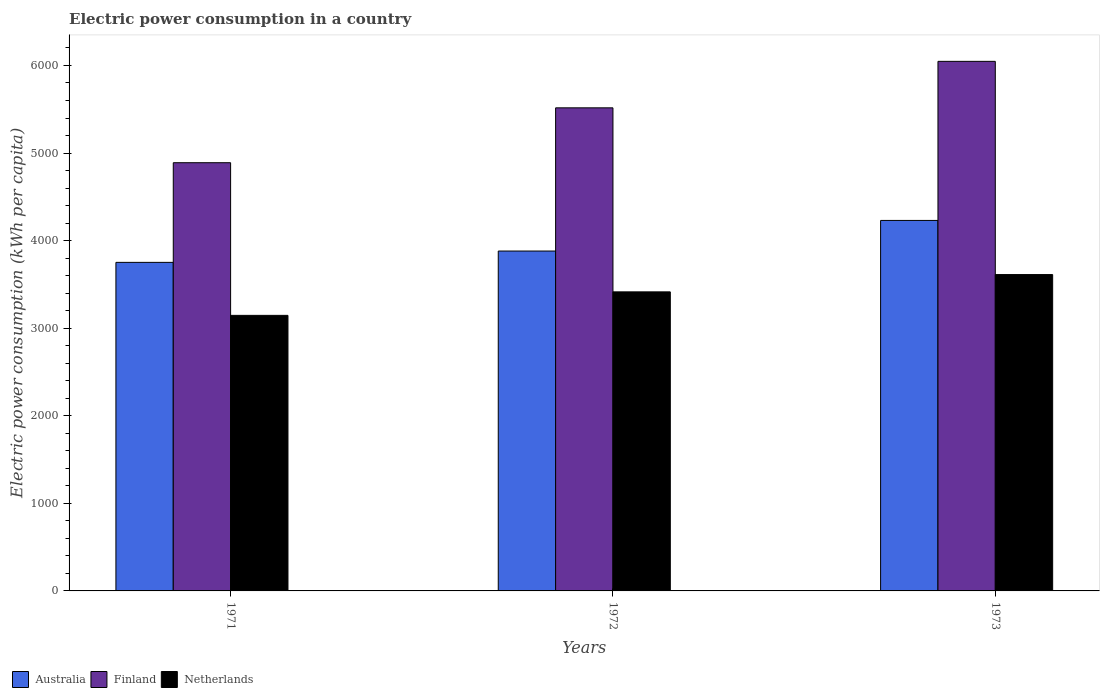How many groups of bars are there?
Your answer should be compact. 3. Are the number of bars on each tick of the X-axis equal?
Offer a very short reply. Yes. What is the label of the 2nd group of bars from the left?
Make the answer very short. 1972. In how many cases, is the number of bars for a given year not equal to the number of legend labels?
Provide a short and direct response. 0. What is the electric power consumption in in Australia in 1972?
Offer a terse response. 3880.93. Across all years, what is the maximum electric power consumption in in Australia?
Offer a very short reply. 4230.34. Across all years, what is the minimum electric power consumption in in Finland?
Provide a succinct answer. 4889.5. In which year was the electric power consumption in in Finland minimum?
Your response must be concise. 1971. What is the total electric power consumption in in Australia in the graph?
Ensure brevity in your answer.  1.19e+04. What is the difference between the electric power consumption in in Finland in 1971 and that in 1972?
Your response must be concise. -626.64. What is the difference between the electric power consumption in in Australia in 1973 and the electric power consumption in in Netherlands in 1971?
Your answer should be very brief. 1083.88. What is the average electric power consumption in in Finland per year?
Ensure brevity in your answer.  5484.16. In the year 1971, what is the difference between the electric power consumption in in Netherlands and electric power consumption in in Finland?
Ensure brevity in your answer.  -1743.04. In how many years, is the electric power consumption in in Netherlands greater than 2200 kWh per capita?
Make the answer very short. 3. What is the ratio of the electric power consumption in in Netherlands in 1972 to that in 1973?
Provide a short and direct response. 0.95. Is the electric power consumption in in Netherlands in 1971 less than that in 1972?
Your answer should be very brief. Yes. What is the difference between the highest and the second highest electric power consumption in in Australia?
Your answer should be very brief. 349.41. What is the difference between the highest and the lowest electric power consumption in in Netherlands?
Your answer should be compact. 465.85. Is the sum of the electric power consumption in in Netherlands in 1972 and 1973 greater than the maximum electric power consumption in in Australia across all years?
Ensure brevity in your answer.  Yes. What does the 2nd bar from the left in 1971 represents?
Ensure brevity in your answer.  Finland. Is it the case that in every year, the sum of the electric power consumption in in Finland and electric power consumption in in Australia is greater than the electric power consumption in in Netherlands?
Your answer should be compact. Yes. How many bars are there?
Give a very brief answer. 9. Are all the bars in the graph horizontal?
Ensure brevity in your answer.  No. How many years are there in the graph?
Offer a very short reply. 3. What is the difference between two consecutive major ticks on the Y-axis?
Your answer should be compact. 1000. Does the graph contain any zero values?
Make the answer very short. No. Where does the legend appear in the graph?
Ensure brevity in your answer.  Bottom left. How many legend labels are there?
Provide a short and direct response. 3. How are the legend labels stacked?
Your answer should be very brief. Horizontal. What is the title of the graph?
Make the answer very short. Electric power consumption in a country. What is the label or title of the Y-axis?
Provide a succinct answer. Electric power consumption (kWh per capita). What is the Electric power consumption (kWh per capita) in Australia in 1971?
Provide a short and direct response. 3751.64. What is the Electric power consumption (kWh per capita) of Finland in 1971?
Make the answer very short. 4889.5. What is the Electric power consumption (kWh per capita) of Netherlands in 1971?
Provide a short and direct response. 3146.46. What is the Electric power consumption (kWh per capita) of Australia in 1972?
Your answer should be compact. 3880.93. What is the Electric power consumption (kWh per capita) in Finland in 1972?
Provide a short and direct response. 5516.14. What is the Electric power consumption (kWh per capita) of Netherlands in 1972?
Your response must be concise. 3414.69. What is the Electric power consumption (kWh per capita) of Australia in 1973?
Your answer should be compact. 4230.34. What is the Electric power consumption (kWh per capita) in Finland in 1973?
Your response must be concise. 6046.83. What is the Electric power consumption (kWh per capita) in Netherlands in 1973?
Your answer should be very brief. 3612.31. Across all years, what is the maximum Electric power consumption (kWh per capita) of Australia?
Your answer should be very brief. 4230.34. Across all years, what is the maximum Electric power consumption (kWh per capita) of Finland?
Provide a short and direct response. 6046.83. Across all years, what is the maximum Electric power consumption (kWh per capita) in Netherlands?
Your answer should be very brief. 3612.31. Across all years, what is the minimum Electric power consumption (kWh per capita) in Australia?
Offer a very short reply. 3751.64. Across all years, what is the minimum Electric power consumption (kWh per capita) in Finland?
Your response must be concise. 4889.5. Across all years, what is the minimum Electric power consumption (kWh per capita) of Netherlands?
Offer a terse response. 3146.46. What is the total Electric power consumption (kWh per capita) in Australia in the graph?
Give a very brief answer. 1.19e+04. What is the total Electric power consumption (kWh per capita) of Finland in the graph?
Keep it short and to the point. 1.65e+04. What is the total Electric power consumption (kWh per capita) of Netherlands in the graph?
Your answer should be very brief. 1.02e+04. What is the difference between the Electric power consumption (kWh per capita) in Australia in 1971 and that in 1972?
Make the answer very short. -129.29. What is the difference between the Electric power consumption (kWh per capita) in Finland in 1971 and that in 1972?
Give a very brief answer. -626.64. What is the difference between the Electric power consumption (kWh per capita) of Netherlands in 1971 and that in 1972?
Keep it short and to the point. -268.23. What is the difference between the Electric power consumption (kWh per capita) of Australia in 1971 and that in 1973?
Offer a terse response. -478.7. What is the difference between the Electric power consumption (kWh per capita) of Finland in 1971 and that in 1973?
Your answer should be compact. -1157.33. What is the difference between the Electric power consumption (kWh per capita) in Netherlands in 1971 and that in 1973?
Make the answer very short. -465.85. What is the difference between the Electric power consumption (kWh per capita) in Australia in 1972 and that in 1973?
Your response must be concise. -349.41. What is the difference between the Electric power consumption (kWh per capita) of Finland in 1972 and that in 1973?
Offer a terse response. -530.69. What is the difference between the Electric power consumption (kWh per capita) of Netherlands in 1972 and that in 1973?
Make the answer very short. -197.62. What is the difference between the Electric power consumption (kWh per capita) in Australia in 1971 and the Electric power consumption (kWh per capita) in Finland in 1972?
Your answer should be compact. -1764.5. What is the difference between the Electric power consumption (kWh per capita) in Australia in 1971 and the Electric power consumption (kWh per capita) in Netherlands in 1972?
Provide a short and direct response. 336.95. What is the difference between the Electric power consumption (kWh per capita) of Finland in 1971 and the Electric power consumption (kWh per capita) of Netherlands in 1972?
Give a very brief answer. 1474.82. What is the difference between the Electric power consumption (kWh per capita) of Australia in 1971 and the Electric power consumption (kWh per capita) of Finland in 1973?
Give a very brief answer. -2295.19. What is the difference between the Electric power consumption (kWh per capita) of Australia in 1971 and the Electric power consumption (kWh per capita) of Netherlands in 1973?
Provide a succinct answer. 139.33. What is the difference between the Electric power consumption (kWh per capita) in Finland in 1971 and the Electric power consumption (kWh per capita) in Netherlands in 1973?
Give a very brief answer. 1277.19. What is the difference between the Electric power consumption (kWh per capita) in Australia in 1972 and the Electric power consumption (kWh per capita) in Finland in 1973?
Offer a terse response. -2165.9. What is the difference between the Electric power consumption (kWh per capita) of Australia in 1972 and the Electric power consumption (kWh per capita) of Netherlands in 1973?
Ensure brevity in your answer.  268.62. What is the difference between the Electric power consumption (kWh per capita) in Finland in 1972 and the Electric power consumption (kWh per capita) in Netherlands in 1973?
Offer a very short reply. 1903.83. What is the average Electric power consumption (kWh per capita) of Australia per year?
Your answer should be very brief. 3954.31. What is the average Electric power consumption (kWh per capita) in Finland per year?
Ensure brevity in your answer.  5484.16. What is the average Electric power consumption (kWh per capita) in Netherlands per year?
Offer a very short reply. 3391.15. In the year 1971, what is the difference between the Electric power consumption (kWh per capita) of Australia and Electric power consumption (kWh per capita) of Finland?
Provide a succinct answer. -1137.86. In the year 1971, what is the difference between the Electric power consumption (kWh per capita) of Australia and Electric power consumption (kWh per capita) of Netherlands?
Your answer should be compact. 605.18. In the year 1971, what is the difference between the Electric power consumption (kWh per capita) of Finland and Electric power consumption (kWh per capita) of Netherlands?
Provide a succinct answer. 1743.04. In the year 1972, what is the difference between the Electric power consumption (kWh per capita) in Australia and Electric power consumption (kWh per capita) in Finland?
Offer a terse response. -1635.21. In the year 1972, what is the difference between the Electric power consumption (kWh per capita) in Australia and Electric power consumption (kWh per capita) in Netherlands?
Offer a terse response. 466.24. In the year 1972, what is the difference between the Electric power consumption (kWh per capita) in Finland and Electric power consumption (kWh per capita) in Netherlands?
Your answer should be very brief. 2101.45. In the year 1973, what is the difference between the Electric power consumption (kWh per capita) of Australia and Electric power consumption (kWh per capita) of Finland?
Provide a short and direct response. -1816.49. In the year 1973, what is the difference between the Electric power consumption (kWh per capita) of Australia and Electric power consumption (kWh per capita) of Netherlands?
Offer a very short reply. 618.03. In the year 1973, what is the difference between the Electric power consumption (kWh per capita) in Finland and Electric power consumption (kWh per capita) in Netherlands?
Your answer should be very brief. 2434.52. What is the ratio of the Electric power consumption (kWh per capita) in Australia in 1971 to that in 1972?
Your answer should be compact. 0.97. What is the ratio of the Electric power consumption (kWh per capita) of Finland in 1971 to that in 1972?
Provide a short and direct response. 0.89. What is the ratio of the Electric power consumption (kWh per capita) in Netherlands in 1971 to that in 1972?
Ensure brevity in your answer.  0.92. What is the ratio of the Electric power consumption (kWh per capita) of Australia in 1971 to that in 1973?
Offer a very short reply. 0.89. What is the ratio of the Electric power consumption (kWh per capita) in Finland in 1971 to that in 1973?
Offer a terse response. 0.81. What is the ratio of the Electric power consumption (kWh per capita) of Netherlands in 1971 to that in 1973?
Your response must be concise. 0.87. What is the ratio of the Electric power consumption (kWh per capita) in Australia in 1972 to that in 1973?
Your response must be concise. 0.92. What is the ratio of the Electric power consumption (kWh per capita) of Finland in 1972 to that in 1973?
Provide a succinct answer. 0.91. What is the ratio of the Electric power consumption (kWh per capita) in Netherlands in 1972 to that in 1973?
Keep it short and to the point. 0.95. What is the difference between the highest and the second highest Electric power consumption (kWh per capita) of Australia?
Your answer should be compact. 349.41. What is the difference between the highest and the second highest Electric power consumption (kWh per capita) in Finland?
Provide a short and direct response. 530.69. What is the difference between the highest and the second highest Electric power consumption (kWh per capita) of Netherlands?
Offer a very short reply. 197.62. What is the difference between the highest and the lowest Electric power consumption (kWh per capita) in Australia?
Keep it short and to the point. 478.7. What is the difference between the highest and the lowest Electric power consumption (kWh per capita) in Finland?
Offer a terse response. 1157.33. What is the difference between the highest and the lowest Electric power consumption (kWh per capita) in Netherlands?
Offer a terse response. 465.85. 